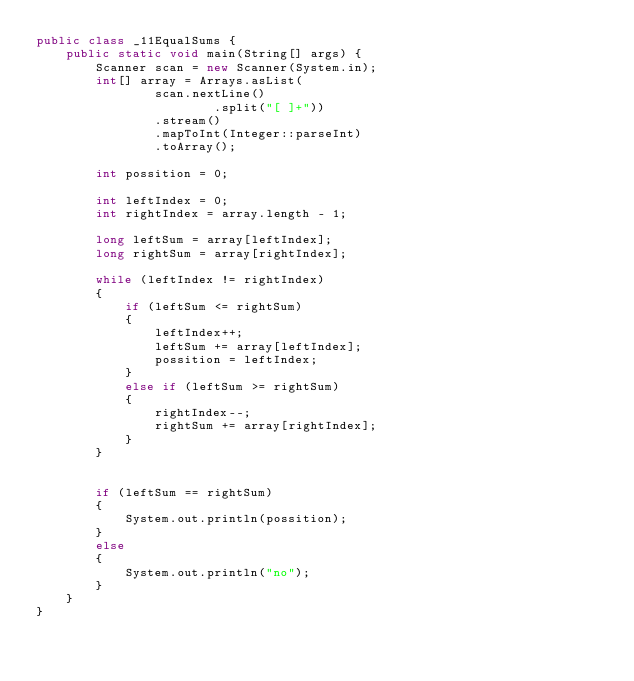<code> <loc_0><loc_0><loc_500><loc_500><_Java_>public class _11EqualSums {
    public static void main(String[] args) {
        Scanner scan = new Scanner(System.in);
        int[] array = Arrays.asList(
                scan.nextLine()
                        .split("[ ]+"))
                .stream()
                .mapToInt(Integer::parseInt)
                .toArray();

        int possition = 0;

        int leftIndex = 0;
        int rightIndex = array.length - 1;

        long leftSum = array[leftIndex];
        long rightSum = array[rightIndex];

        while (leftIndex != rightIndex)
        {
            if (leftSum <= rightSum)
            {
                leftIndex++;
                leftSum += array[leftIndex];
                possition = leftIndex;
            }
            else if (leftSum >= rightSum)
            {
                rightIndex--;
                rightSum += array[rightIndex];
            }
        }


        if (leftSum == rightSum)
        {
            System.out.println(possition);
        }
        else
        {
            System.out.println("no");
        }
    }
}
</code> 